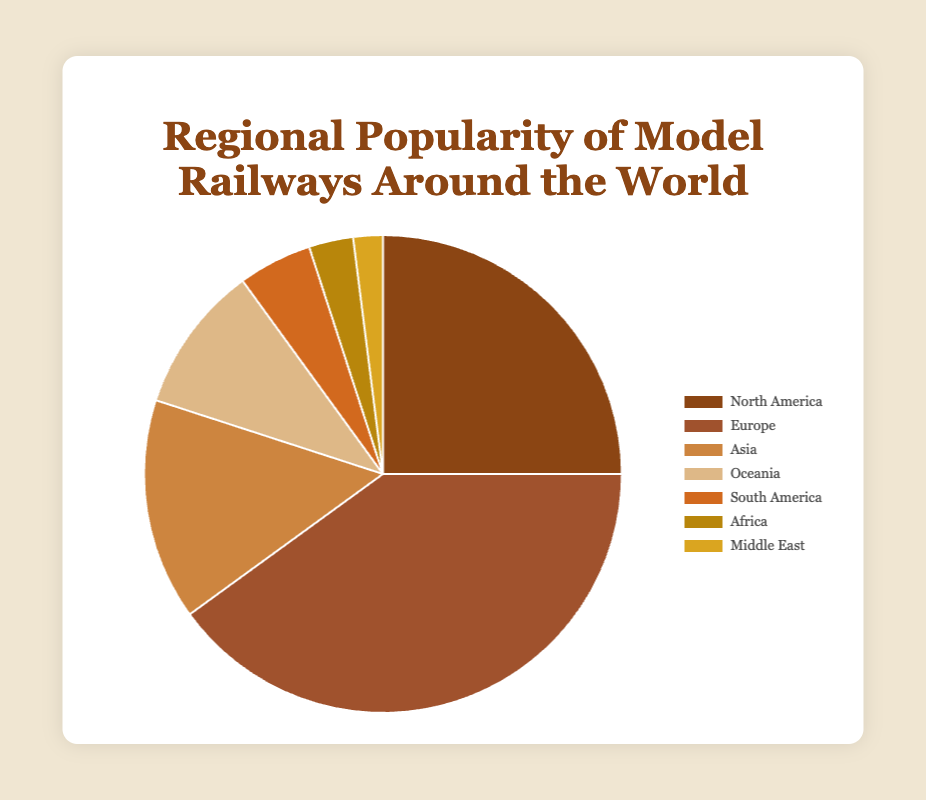Which region has the highest popularity for model railways? According to the pie chart, Europe has the highest popularity percentage for model railways with 40%.
Answer: Europe What is the combined popularity percentage of model railways in North America and Europe? You need to sum the popularity percentages for North America and Europe. North America has 25% and Europe has 40%, so the combined percentage is 25% + 40% = 65%.
Answer: 65% By how much does the popularity of model railways in Asia differ from Oceania? The popularity percentage for Asia is 15%, and for Oceania it is 10%. The difference is 15% - 10% = 5%.
Answer: 5% Which region has the least popularity for model railways? The pie chart shows that the Middle East has the least popularity percentage for model railways, with only 2%.
Answer: Middle East What is the average popularity percentage of model railways in South America, Africa, and the Middle East? To find the average, you add the percentages for South America (5%), Africa (3%), and the Middle East (2%) and then divide by 3. (5% + 3% + 2%) / 3 = 10% / 3 ≈ 3.33%.
Answer: 3.33% Which two regions together make up less than 10% of the global popularity? Analyzing the chart, Africa (3%) and the Middle East (2%) together make up 3% + 2% = 5%, which is less than 10%.
Answer: Africa and Middle East Compare the popularity of model railways in Oceania to South America. Which region is more popular, and by how much? Oceania has a popularity percentage of 10%, and South America has 5%. Oceania is more popular by 10% - 5% = 5%.
Answer: Oceania by 5% What's the difference in popularity percentage between the region with the highest and the region with the lowest popularity? The region with the highest popularity is Europe (40%), and the region with the lowest is the Middle East (2%). The difference is 40% - 2% = 38%.
Answer: 38% If we combine the popularity percentages of Asia, Oceania, South America, Africa, and the Middle East, does it surpass that of Europe? By how much? Sum the popularity percentages of Asia (15%), Oceania (10%), South America (5%), Africa (3%), and the Middle East (2%). 15% + 10% + 5% + 3% + 2% = 35%. Europe has 40%, so it does not surpass Europe. Europe surpasses by 40% - 35% = 5%.
Answer: No, Europe surpasses by 5% 